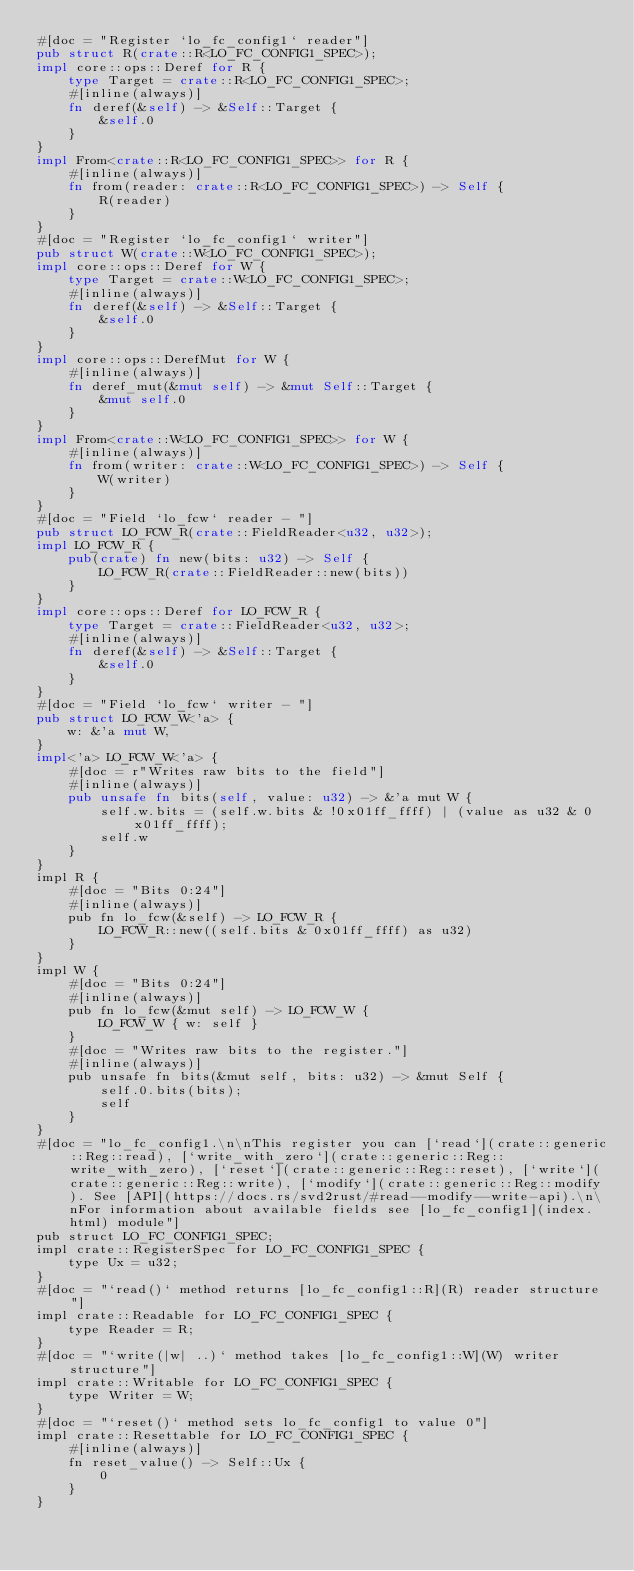<code> <loc_0><loc_0><loc_500><loc_500><_Rust_>#[doc = "Register `lo_fc_config1` reader"]
pub struct R(crate::R<LO_FC_CONFIG1_SPEC>);
impl core::ops::Deref for R {
    type Target = crate::R<LO_FC_CONFIG1_SPEC>;
    #[inline(always)]
    fn deref(&self) -> &Self::Target {
        &self.0
    }
}
impl From<crate::R<LO_FC_CONFIG1_SPEC>> for R {
    #[inline(always)]
    fn from(reader: crate::R<LO_FC_CONFIG1_SPEC>) -> Self {
        R(reader)
    }
}
#[doc = "Register `lo_fc_config1` writer"]
pub struct W(crate::W<LO_FC_CONFIG1_SPEC>);
impl core::ops::Deref for W {
    type Target = crate::W<LO_FC_CONFIG1_SPEC>;
    #[inline(always)]
    fn deref(&self) -> &Self::Target {
        &self.0
    }
}
impl core::ops::DerefMut for W {
    #[inline(always)]
    fn deref_mut(&mut self) -> &mut Self::Target {
        &mut self.0
    }
}
impl From<crate::W<LO_FC_CONFIG1_SPEC>> for W {
    #[inline(always)]
    fn from(writer: crate::W<LO_FC_CONFIG1_SPEC>) -> Self {
        W(writer)
    }
}
#[doc = "Field `lo_fcw` reader - "]
pub struct LO_FCW_R(crate::FieldReader<u32, u32>);
impl LO_FCW_R {
    pub(crate) fn new(bits: u32) -> Self {
        LO_FCW_R(crate::FieldReader::new(bits))
    }
}
impl core::ops::Deref for LO_FCW_R {
    type Target = crate::FieldReader<u32, u32>;
    #[inline(always)]
    fn deref(&self) -> &Self::Target {
        &self.0
    }
}
#[doc = "Field `lo_fcw` writer - "]
pub struct LO_FCW_W<'a> {
    w: &'a mut W,
}
impl<'a> LO_FCW_W<'a> {
    #[doc = r"Writes raw bits to the field"]
    #[inline(always)]
    pub unsafe fn bits(self, value: u32) -> &'a mut W {
        self.w.bits = (self.w.bits & !0x01ff_ffff) | (value as u32 & 0x01ff_ffff);
        self.w
    }
}
impl R {
    #[doc = "Bits 0:24"]
    #[inline(always)]
    pub fn lo_fcw(&self) -> LO_FCW_R {
        LO_FCW_R::new((self.bits & 0x01ff_ffff) as u32)
    }
}
impl W {
    #[doc = "Bits 0:24"]
    #[inline(always)]
    pub fn lo_fcw(&mut self) -> LO_FCW_W {
        LO_FCW_W { w: self }
    }
    #[doc = "Writes raw bits to the register."]
    #[inline(always)]
    pub unsafe fn bits(&mut self, bits: u32) -> &mut Self {
        self.0.bits(bits);
        self
    }
}
#[doc = "lo_fc_config1.\n\nThis register you can [`read`](crate::generic::Reg::read), [`write_with_zero`](crate::generic::Reg::write_with_zero), [`reset`](crate::generic::Reg::reset), [`write`](crate::generic::Reg::write), [`modify`](crate::generic::Reg::modify). See [API](https://docs.rs/svd2rust/#read--modify--write-api).\n\nFor information about available fields see [lo_fc_config1](index.html) module"]
pub struct LO_FC_CONFIG1_SPEC;
impl crate::RegisterSpec for LO_FC_CONFIG1_SPEC {
    type Ux = u32;
}
#[doc = "`read()` method returns [lo_fc_config1::R](R) reader structure"]
impl crate::Readable for LO_FC_CONFIG1_SPEC {
    type Reader = R;
}
#[doc = "`write(|w| ..)` method takes [lo_fc_config1::W](W) writer structure"]
impl crate::Writable for LO_FC_CONFIG1_SPEC {
    type Writer = W;
}
#[doc = "`reset()` method sets lo_fc_config1 to value 0"]
impl crate::Resettable for LO_FC_CONFIG1_SPEC {
    #[inline(always)]
    fn reset_value() -> Self::Ux {
        0
    }
}
</code> 